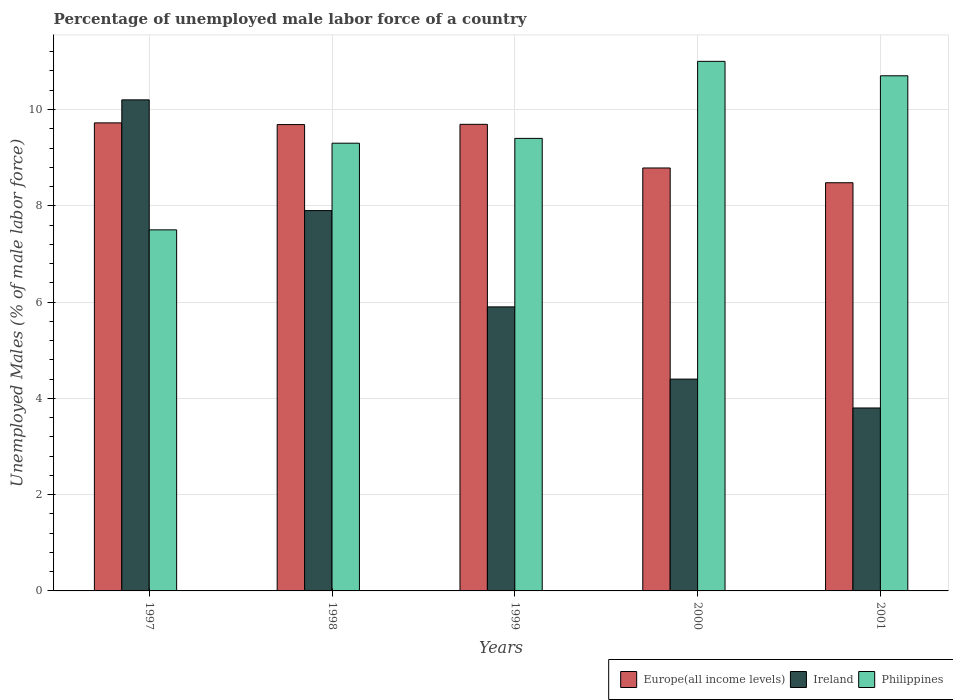How many different coloured bars are there?
Provide a short and direct response. 3. How many groups of bars are there?
Provide a short and direct response. 5. How many bars are there on the 5th tick from the right?
Your response must be concise. 3. What is the percentage of unemployed male labor force in Europe(all income levels) in 2001?
Your response must be concise. 8.48. Across all years, what is the maximum percentage of unemployed male labor force in Europe(all income levels)?
Your answer should be compact. 9.72. Across all years, what is the minimum percentage of unemployed male labor force in Europe(all income levels)?
Ensure brevity in your answer.  8.48. What is the total percentage of unemployed male labor force in Philippines in the graph?
Provide a succinct answer. 47.9. What is the difference between the percentage of unemployed male labor force in Ireland in 1998 and that in 1999?
Keep it short and to the point. 2. What is the difference between the percentage of unemployed male labor force in Ireland in 1998 and the percentage of unemployed male labor force in Philippines in 1999?
Your answer should be compact. -1.5. What is the average percentage of unemployed male labor force in Ireland per year?
Provide a succinct answer. 6.44. In the year 1998, what is the difference between the percentage of unemployed male labor force in Philippines and percentage of unemployed male labor force in Ireland?
Provide a short and direct response. 1.4. What is the ratio of the percentage of unemployed male labor force in Europe(all income levels) in 1999 to that in 2000?
Provide a short and direct response. 1.1. Is the percentage of unemployed male labor force in Ireland in 1999 less than that in 2000?
Your response must be concise. No. What is the difference between the highest and the second highest percentage of unemployed male labor force in Philippines?
Your answer should be very brief. 0.3. What is the difference between the highest and the lowest percentage of unemployed male labor force in Ireland?
Your response must be concise. 6.4. What does the 1st bar from the left in 1998 represents?
Offer a very short reply. Europe(all income levels). What does the 2nd bar from the right in 1997 represents?
Your answer should be compact. Ireland. Are all the bars in the graph horizontal?
Give a very brief answer. No. How many years are there in the graph?
Provide a short and direct response. 5. Does the graph contain grids?
Give a very brief answer. Yes. Where does the legend appear in the graph?
Your answer should be compact. Bottom right. What is the title of the graph?
Offer a very short reply. Percentage of unemployed male labor force of a country. Does "Malawi" appear as one of the legend labels in the graph?
Give a very brief answer. No. What is the label or title of the Y-axis?
Give a very brief answer. Unemployed Males (% of male labor force). What is the Unemployed Males (% of male labor force) of Europe(all income levels) in 1997?
Your answer should be very brief. 9.72. What is the Unemployed Males (% of male labor force) of Ireland in 1997?
Give a very brief answer. 10.2. What is the Unemployed Males (% of male labor force) of Europe(all income levels) in 1998?
Your response must be concise. 9.69. What is the Unemployed Males (% of male labor force) in Ireland in 1998?
Provide a short and direct response. 7.9. What is the Unemployed Males (% of male labor force) in Philippines in 1998?
Make the answer very short. 9.3. What is the Unemployed Males (% of male labor force) in Europe(all income levels) in 1999?
Give a very brief answer. 9.69. What is the Unemployed Males (% of male labor force) in Ireland in 1999?
Make the answer very short. 5.9. What is the Unemployed Males (% of male labor force) of Philippines in 1999?
Keep it short and to the point. 9.4. What is the Unemployed Males (% of male labor force) in Europe(all income levels) in 2000?
Your answer should be compact. 8.79. What is the Unemployed Males (% of male labor force) in Ireland in 2000?
Ensure brevity in your answer.  4.4. What is the Unemployed Males (% of male labor force) in Philippines in 2000?
Provide a succinct answer. 11. What is the Unemployed Males (% of male labor force) in Europe(all income levels) in 2001?
Offer a very short reply. 8.48. What is the Unemployed Males (% of male labor force) in Ireland in 2001?
Keep it short and to the point. 3.8. What is the Unemployed Males (% of male labor force) in Philippines in 2001?
Keep it short and to the point. 10.7. Across all years, what is the maximum Unemployed Males (% of male labor force) of Europe(all income levels)?
Ensure brevity in your answer.  9.72. Across all years, what is the maximum Unemployed Males (% of male labor force) of Ireland?
Your answer should be compact. 10.2. Across all years, what is the minimum Unemployed Males (% of male labor force) in Europe(all income levels)?
Keep it short and to the point. 8.48. Across all years, what is the minimum Unemployed Males (% of male labor force) of Ireland?
Your answer should be compact. 3.8. Across all years, what is the minimum Unemployed Males (% of male labor force) of Philippines?
Provide a short and direct response. 7.5. What is the total Unemployed Males (% of male labor force) in Europe(all income levels) in the graph?
Your response must be concise. 46.36. What is the total Unemployed Males (% of male labor force) of Ireland in the graph?
Make the answer very short. 32.2. What is the total Unemployed Males (% of male labor force) in Philippines in the graph?
Keep it short and to the point. 47.9. What is the difference between the Unemployed Males (% of male labor force) in Europe(all income levels) in 1997 and that in 1998?
Give a very brief answer. 0.04. What is the difference between the Unemployed Males (% of male labor force) of Europe(all income levels) in 1997 and that in 1999?
Provide a short and direct response. 0.03. What is the difference between the Unemployed Males (% of male labor force) of Ireland in 1997 and that in 1999?
Offer a terse response. 4.3. What is the difference between the Unemployed Males (% of male labor force) of Europe(all income levels) in 1997 and that in 2000?
Keep it short and to the point. 0.94. What is the difference between the Unemployed Males (% of male labor force) in Europe(all income levels) in 1997 and that in 2001?
Provide a succinct answer. 1.24. What is the difference between the Unemployed Males (% of male labor force) in Ireland in 1997 and that in 2001?
Your response must be concise. 6.4. What is the difference between the Unemployed Males (% of male labor force) in Philippines in 1997 and that in 2001?
Offer a very short reply. -3.2. What is the difference between the Unemployed Males (% of male labor force) in Europe(all income levels) in 1998 and that in 1999?
Keep it short and to the point. -0.01. What is the difference between the Unemployed Males (% of male labor force) in Europe(all income levels) in 1998 and that in 2000?
Give a very brief answer. 0.9. What is the difference between the Unemployed Males (% of male labor force) of Ireland in 1998 and that in 2000?
Ensure brevity in your answer.  3.5. What is the difference between the Unemployed Males (% of male labor force) of Europe(all income levels) in 1998 and that in 2001?
Your answer should be compact. 1.21. What is the difference between the Unemployed Males (% of male labor force) in Europe(all income levels) in 1999 and that in 2000?
Make the answer very short. 0.91. What is the difference between the Unemployed Males (% of male labor force) in Ireland in 1999 and that in 2000?
Provide a short and direct response. 1.5. What is the difference between the Unemployed Males (% of male labor force) in Philippines in 1999 and that in 2000?
Ensure brevity in your answer.  -1.6. What is the difference between the Unemployed Males (% of male labor force) of Europe(all income levels) in 1999 and that in 2001?
Your answer should be very brief. 1.21. What is the difference between the Unemployed Males (% of male labor force) of Europe(all income levels) in 2000 and that in 2001?
Give a very brief answer. 0.31. What is the difference between the Unemployed Males (% of male labor force) of Philippines in 2000 and that in 2001?
Offer a very short reply. 0.3. What is the difference between the Unemployed Males (% of male labor force) in Europe(all income levels) in 1997 and the Unemployed Males (% of male labor force) in Ireland in 1998?
Your answer should be very brief. 1.82. What is the difference between the Unemployed Males (% of male labor force) in Europe(all income levels) in 1997 and the Unemployed Males (% of male labor force) in Philippines in 1998?
Provide a succinct answer. 0.42. What is the difference between the Unemployed Males (% of male labor force) in Ireland in 1997 and the Unemployed Males (% of male labor force) in Philippines in 1998?
Make the answer very short. 0.9. What is the difference between the Unemployed Males (% of male labor force) of Europe(all income levels) in 1997 and the Unemployed Males (% of male labor force) of Ireland in 1999?
Your answer should be compact. 3.82. What is the difference between the Unemployed Males (% of male labor force) of Europe(all income levels) in 1997 and the Unemployed Males (% of male labor force) of Philippines in 1999?
Make the answer very short. 0.32. What is the difference between the Unemployed Males (% of male labor force) in Europe(all income levels) in 1997 and the Unemployed Males (% of male labor force) in Ireland in 2000?
Offer a very short reply. 5.32. What is the difference between the Unemployed Males (% of male labor force) of Europe(all income levels) in 1997 and the Unemployed Males (% of male labor force) of Philippines in 2000?
Your answer should be very brief. -1.28. What is the difference between the Unemployed Males (% of male labor force) in Europe(all income levels) in 1997 and the Unemployed Males (% of male labor force) in Ireland in 2001?
Offer a terse response. 5.92. What is the difference between the Unemployed Males (% of male labor force) in Europe(all income levels) in 1997 and the Unemployed Males (% of male labor force) in Philippines in 2001?
Offer a very short reply. -0.98. What is the difference between the Unemployed Males (% of male labor force) in Europe(all income levels) in 1998 and the Unemployed Males (% of male labor force) in Ireland in 1999?
Offer a very short reply. 3.79. What is the difference between the Unemployed Males (% of male labor force) in Europe(all income levels) in 1998 and the Unemployed Males (% of male labor force) in Philippines in 1999?
Provide a short and direct response. 0.29. What is the difference between the Unemployed Males (% of male labor force) in Ireland in 1998 and the Unemployed Males (% of male labor force) in Philippines in 1999?
Your answer should be compact. -1.5. What is the difference between the Unemployed Males (% of male labor force) in Europe(all income levels) in 1998 and the Unemployed Males (% of male labor force) in Ireland in 2000?
Your answer should be very brief. 5.29. What is the difference between the Unemployed Males (% of male labor force) of Europe(all income levels) in 1998 and the Unemployed Males (% of male labor force) of Philippines in 2000?
Make the answer very short. -1.31. What is the difference between the Unemployed Males (% of male labor force) of Ireland in 1998 and the Unemployed Males (% of male labor force) of Philippines in 2000?
Make the answer very short. -3.1. What is the difference between the Unemployed Males (% of male labor force) of Europe(all income levels) in 1998 and the Unemployed Males (% of male labor force) of Ireland in 2001?
Make the answer very short. 5.89. What is the difference between the Unemployed Males (% of male labor force) in Europe(all income levels) in 1998 and the Unemployed Males (% of male labor force) in Philippines in 2001?
Your answer should be compact. -1.01. What is the difference between the Unemployed Males (% of male labor force) in Ireland in 1998 and the Unemployed Males (% of male labor force) in Philippines in 2001?
Your answer should be compact. -2.8. What is the difference between the Unemployed Males (% of male labor force) in Europe(all income levels) in 1999 and the Unemployed Males (% of male labor force) in Ireland in 2000?
Your answer should be very brief. 5.29. What is the difference between the Unemployed Males (% of male labor force) in Europe(all income levels) in 1999 and the Unemployed Males (% of male labor force) in Philippines in 2000?
Ensure brevity in your answer.  -1.31. What is the difference between the Unemployed Males (% of male labor force) of Ireland in 1999 and the Unemployed Males (% of male labor force) of Philippines in 2000?
Offer a terse response. -5.1. What is the difference between the Unemployed Males (% of male labor force) in Europe(all income levels) in 1999 and the Unemployed Males (% of male labor force) in Ireland in 2001?
Keep it short and to the point. 5.89. What is the difference between the Unemployed Males (% of male labor force) of Europe(all income levels) in 1999 and the Unemployed Males (% of male labor force) of Philippines in 2001?
Your answer should be compact. -1.01. What is the difference between the Unemployed Males (% of male labor force) in Ireland in 1999 and the Unemployed Males (% of male labor force) in Philippines in 2001?
Make the answer very short. -4.8. What is the difference between the Unemployed Males (% of male labor force) in Europe(all income levels) in 2000 and the Unemployed Males (% of male labor force) in Ireland in 2001?
Provide a succinct answer. 4.99. What is the difference between the Unemployed Males (% of male labor force) in Europe(all income levels) in 2000 and the Unemployed Males (% of male labor force) in Philippines in 2001?
Ensure brevity in your answer.  -1.91. What is the average Unemployed Males (% of male labor force) in Europe(all income levels) per year?
Ensure brevity in your answer.  9.27. What is the average Unemployed Males (% of male labor force) of Ireland per year?
Make the answer very short. 6.44. What is the average Unemployed Males (% of male labor force) in Philippines per year?
Provide a short and direct response. 9.58. In the year 1997, what is the difference between the Unemployed Males (% of male labor force) of Europe(all income levels) and Unemployed Males (% of male labor force) of Ireland?
Keep it short and to the point. -0.48. In the year 1997, what is the difference between the Unemployed Males (% of male labor force) of Europe(all income levels) and Unemployed Males (% of male labor force) of Philippines?
Make the answer very short. 2.22. In the year 1997, what is the difference between the Unemployed Males (% of male labor force) in Ireland and Unemployed Males (% of male labor force) in Philippines?
Provide a succinct answer. 2.7. In the year 1998, what is the difference between the Unemployed Males (% of male labor force) of Europe(all income levels) and Unemployed Males (% of male labor force) of Ireland?
Give a very brief answer. 1.79. In the year 1998, what is the difference between the Unemployed Males (% of male labor force) in Europe(all income levels) and Unemployed Males (% of male labor force) in Philippines?
Keep it short and to the point. 0.39. In the year 1999, what is the difference between the Unemployed Males (% of male labor force) of Europe(all income levels) and Unemployed Males (% of male labor force) of Ireland?
Provide a succinct answer. 3.79. In the year 1999, what is the difference between the Unemployed Males (% of male labor force) of Europe(all income levels) and Unemployed Males (% of male labor force) of Philippines?
Provide a short and direct response. 0.29. In the year 2000, what is the difference between the Unemployed Males (% of male labor force) of Europe(all income levels) and Unemployed Males (% of male labor force) of Ireland?
Make the answer very short. 4.39. In the year 2000, what is the difference between the Unemployed Males (% of male labor force) of Europe(all income levels) and Unemployed Males (% of male labor force) of Philippines?
Your answer should be compact. -2.21. In the year 2000, what is the difference between the Unemployed Males (% of male labor force) in Ireland and Unemployed Males (% of male labor force) in Philippines?
Your answer should be very brief. -6.6. In the year 2001, what is the difference between the Unemployed Males (% of male labor force) in Europe(all income levels) and Unemployed Males (% of male labor force) in Ireland?
Offer a terse response. 4.68. In the year 2001, what is the difference between the Unemployed Males (% of male labor force) of Europe(all income levels) and Unemployed Males (% of male labor force) of Philippines?
Your answer should be very brief. -2.22. What is the ratio of the Unemployed Males (% of male labor force) of Europe(all income levels) in 1997 to that in 1998?
Provide a short and direct response. 1. What is the ratio of the Unemployed Males (% of male labor force) in Ireland in 1997 to that in 1998?
Make the answer very short. 1.29. What is the ratio of the Unemployed Males (% of male labor force) in Philippines in 1997 to that in 1998?
Provide a succinct answer. 0.81. What is the ratio of the Unemployed Males (% of male labor force) of Ireland in 1997 to that in 1999?
Your answer should be compact. 1.73. What is the ratio of the Unemployed Males (% of male labor force) in Philippines in 1997 to that in 1999?
Ensure brevity in your answer.  0.8. What is the ratio of the Unemployed Males (% of male labor force) of Europe(all income levels) in 1997 to that in 2000?
Make the answer very short. 1.11. What is the ratio of the Unemployed Males (% of male labor force) in Ireland in 1997 to that in 2000?
Your answer should be compact. 2.32. What is the ratio of the Unemployed Males (% of male labor force) of Philippines in 1997 to that in 2000?
Provide a short and direct response. 0.68. What is the ratio of the Unemployed Males (% of male labor force) in Europe(all income levels) in 1997 to that in 2001?
Provide a short and direct response. 1.15. What is the ratio of the Unemployed Males (% of male labor force) of Ireland in 1997 to that in 2001?
Your answer should be very brief. 2.68. What is the ratio of the Unemployed Males (% of male labor force) of Philippines in 1997 to that in 2001?
Make the answer very short. 0.7. What is the ratio of the Unemployed Males (% of male labor force) of Europe(all income levels) in 1998 to that in 1999?
Make the answer very short. 1. What is the ratio of the Unemployed Males (% of male labor force) of Ireland in 1998 to that in 1999?
Provide a short and direct response. 1.34. What is the ratio of the Unemployed Males (% of male labor force) in Europe(all income levels) in 1998 to that in 2000?
Your answer should be very brief. 1.1. What is the ratio of the Unemployed Males (% of male labor force) in Ireland in 1998 to that in 2000?
Ensure brevity in your answer.  1.8. What is the ratio of the Unemployed Males (% of male labor force) of Philippines in 1998 to that in 2000?
Keep it short and to the point. 0.85. What is the ratio of the Unemployed Males (% of male labor force) in Europe(all income levels) in 1998 to that in 2001?
Provide a short and direct response. 1.14. What is the ratio of the Unemployed Males (% of male labor force) in Ireland in 1998 to that in 2001?
Provide a succinct answer. 2.08. What is the ratio of the Unemployed Males (% of male labor force) in Philippines in 1998 to that in 2001?
Ensure brevity in your answer.  0.87. What is the ratio of the Unemployed Males (% of male labor force) of Europe(all income levels) in 1999 to that in 2000?
Keep it short and to the point. 1.1. What is the ratio of the Unemployed Males (% of male labor force) of Ireland in 1999 to that in 2000?
Make the answer very short. 1.34. What is the ratio of the Unemployed Males (% of male labor force) in Philippines in 1999 to that in 2000?
Keep it short and to the point. 0.85. What is the ratio of the Unemployed Males (% of male labor force) of Europe(all income levels) in 1999 to that in 2001?
Offer a terse response. 1.14. What is the ratio of the Unemployed Males (% of male labor force) of Ireland in 1999 to that in 2001?
Provide a succinct answer. 1.55. What is the ratio of the Unemployed Males (% of male labor force) in Philippines in 1999 to that in 2001?
Give a very brief answer. 0.88. What is the ratio of the Unemployed Males (% of male labor force) of Europe(all income levels) in 2000 to that in 2001?
Your answer should be compact. 1.04. What is the ratio of the Unemployed Males (% of male labor force) of Ireland in 2000 to that in 2001?
Ensure brevity in your answer.  1.16. What is the ratio of the Unemployed Males (% of male labor force) of Philippines in 2000 to that in 2001?
Your answer should be very brief. 1.03. What is the difference between the highest and the second highest Unemployed Males (% of male labor force) in Europe(all income levels)?
Make the answer very short. 0.03. What is the difference between the highest and the second highest Unemployed Males (% of male labor force) of Ireland?
Your response must be concise. 2.3. What is the difference between the highest and the lowest Unemployed Males (% of male labor force) in Europe(all income levels)?
Offer a very short reply. 1.24. What is the difference between the highest and the lowest Unemployed Males (% of male labor force) in Philippines?
Keep it short and to the point. 3.5. 